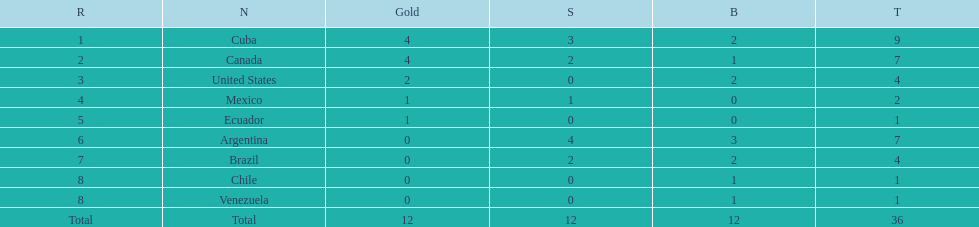How many total medals did brazil received? 4. 